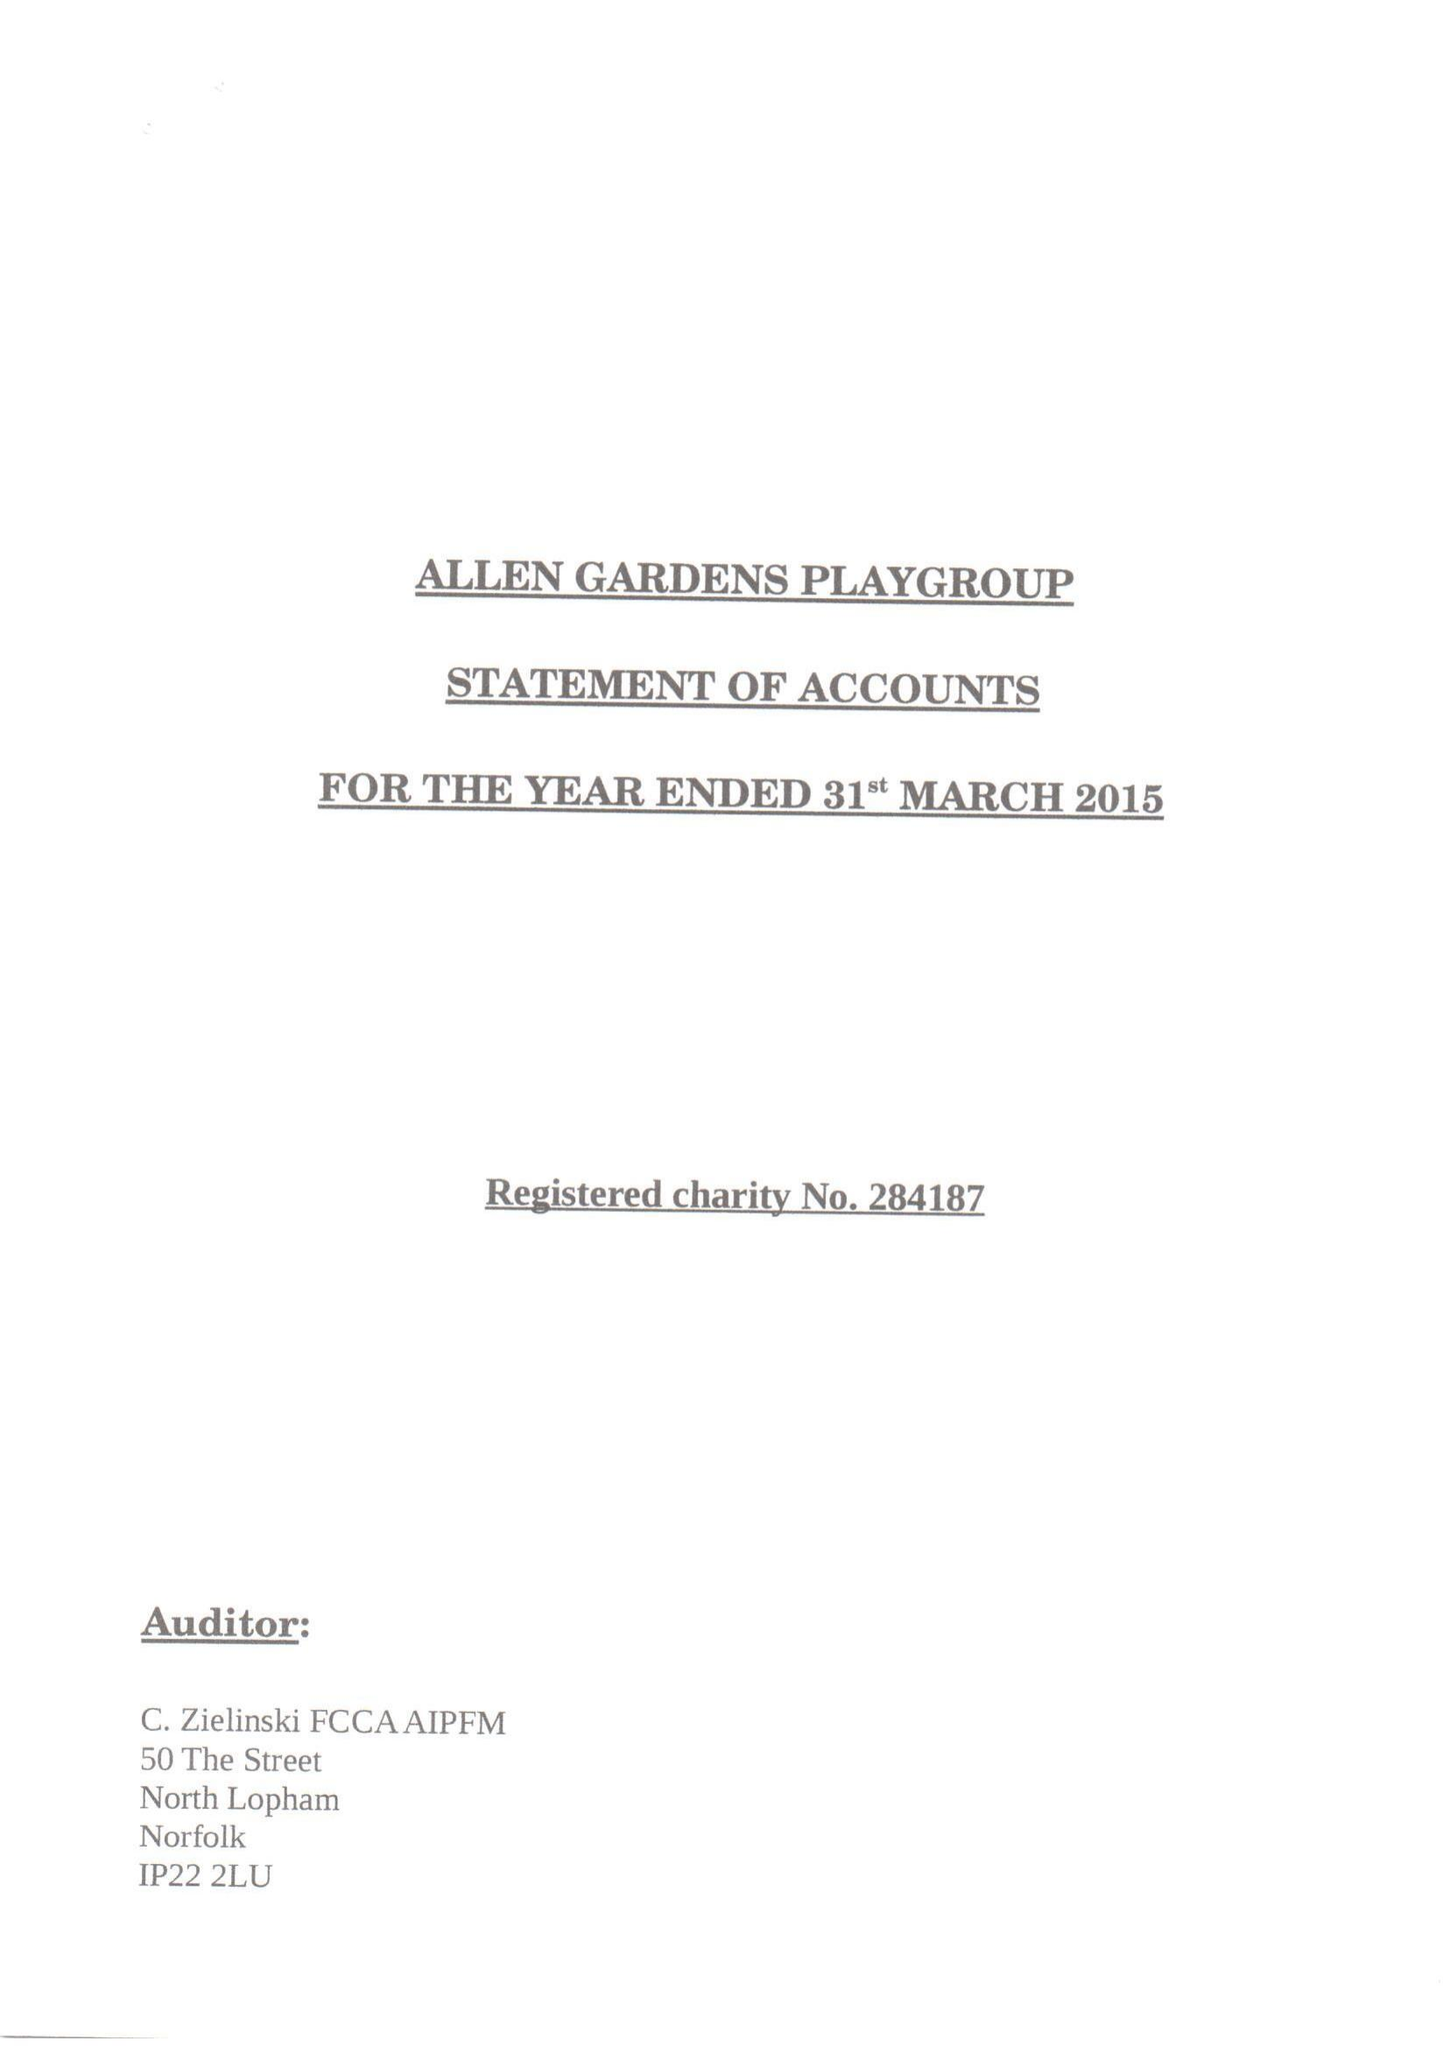What is the value for the address__street_line?
Answer the question using a single word or phrase. 55 BUXTON STREET 